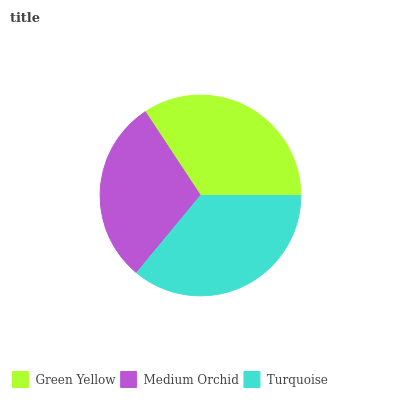Is Medium Orchid the minimum?
Answer yes or no. Yes. Is Turquoise the maximum?
Answer yes or no. Yes. Is Turquoise the minimum?
Answer yes or no. No. Is Medium Orchid the maximum?
Answer yes or no. No. Is Turquoise greater than Medium Orchid?
Answer yes or no. Yes. Is Medium Orchid less than Turquoise?
Answer yes or no. Yes. Is Medium Orchid greater than Turquoise?
Answer yes or no. No. Is Turquoise less than Medium Orchid?
Answer yes or no. No. Is Green Yellow the high median?
Answer yes or no. Yes. Is Green Yellow the low median?
Answer yes or no. Yes. Is Medium Orchid the high median?
Answer yes or no. No. Is Medium Orchid the low median?
Answer yes or no. No. 